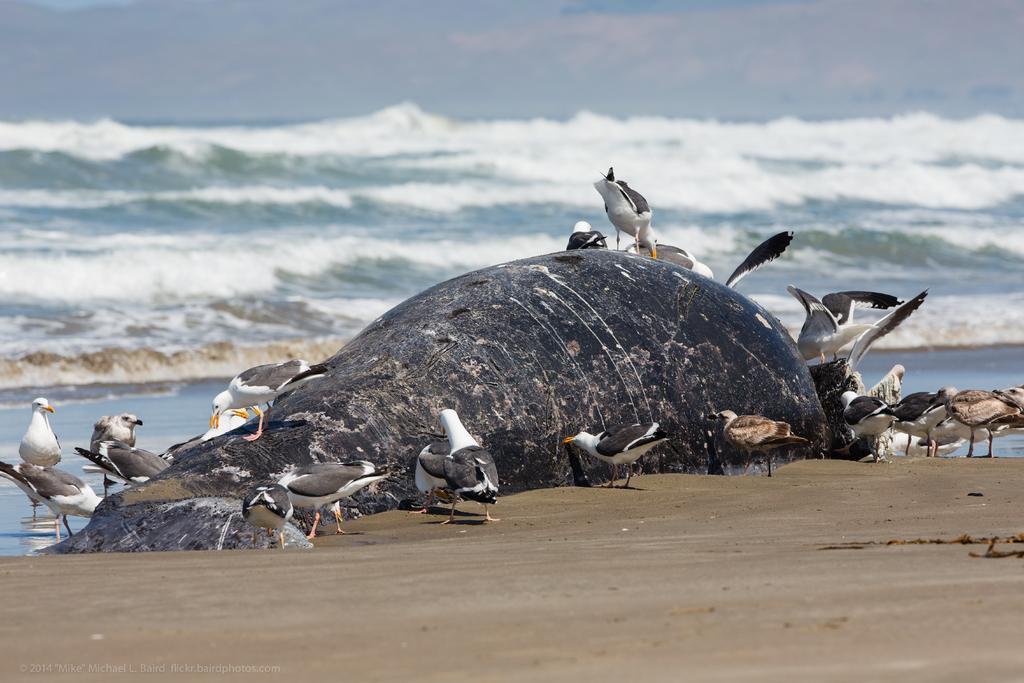How would you summarize this image in a sentence or two? In this picture we can see the ground, here we can see a fish, birds and we can see water in the background. 